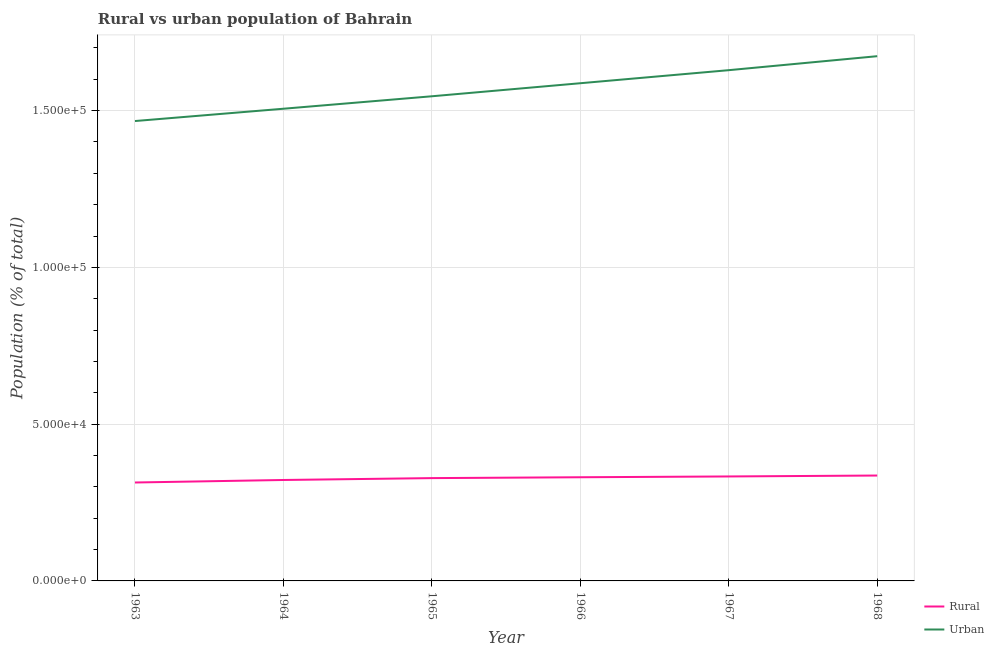Is the number of lines equal to the number of legend labels?
Offer a very short reply. Yes. What is the urban population density in 1966?
Offer a very short reply. 1.59e+05. Across all years, what is the maximum urban population density?
Your response must be concise. 1.67e+05. Across all years, what is the minimum urban population density?
Give a very brief answer. 1.47e+05. In which year was the rural population density maximum?
Your response must be concise. 1968. What is the total urban population density in the graph?
Keep it short and to the point. 9.41e+05. What is the difference between the urban population density in 1965 and that in 1967?
Make the answer very short. -8324. What is the difference between the urban population density in 1966 and the rural population density in 1963?
Your response must be concise. 1.27e+05. What is the average urban population density per year?
Offer a terse response. 1.57e+05. In the year 1963, what is the difference between the rural population density and urban population density?
Offer a terse response. -1.15e+05. What is the ratio of the rural population density in 1963 to that in 1964?
Your answer should be very brief. 0.98. Is the rural population density in 1967 less than that in 1968?
Provide a short and direct response. Yes. Is the difference between the urban population density in 1963 and 1964 greater than the difference between the rural population density in 1963 and 1964?
Ensure brevity in your answer.  No. What is the difference between the highest and the second highest rural population density?
Provide a short and direct response. 292. What is the difference between the highest and the lowest rural population density?
Keep it short and to the point. 2223. How many lines are there?
Your answer should be very brief. 2. How many years are there in the graph?
Ensure brevity in your answer.  6. Are the values on the major ticks of Y-axis written in scientific E-notation?
Your answer should be very brief. Yes. Does the graph contain any zero values?
Provide a short and direct response. No. Does the graph contain grids?
Offer a terse response. Yes. How many legend labels are there?
Offer a terse response. 2. How are the legend labels stacked?
Offer a very short reply. Vertical. What is the title of the graph?
Your answer should be compact. Rural vs urban population of Bahrain. Does "Money lenders" appear as one of the legend labels in the graph?
Make the answer very short. No. What is the label or title of the X-axis?
Your answer should be very brief. Year. What is the label or title of the Y-axis?
Your response must be concise. Population (% of total). What is the Population (% of total) in Rural in 1963?
Your answer should be very brief. 3.14e+04. What is the Population (% of total) in Urban in 1963?
Give a very brief answer. 1.47e+05. What is the Population (% of total) in Rural in 1964?
Your answer should be very brief. 3.22e+04. What is the Population (% of total) in Urban in 1964?
Ensure brevity in your answer.  1.51e+05. What is the Population (% of total) in Rural in 1965?
Keep it short and to the point. 3.28e+04. What is the Population (% of total) of Urban in 1965?
Ensure brevity in your answer.  1.55e+05. What is the Population (% of total) in Rural in 1966?
Give a very brief answer. 3.31e+04. What is the Population (% of total) in Urban in 1966?
Offer a terse response. 1.59e+05. What is the Population (% of total) of Rural in 1967?
Make the answer very short. 3.33e+04. What is the Population (% of total) of Urban in 1967?
Offer a terse response. 1.63e+05. What is the Population (% of total) in Rural in 1968?
Give a very brief answer. 3.36e+04. What is the Population (% of total) of Urban in 1968?
Your answer should be compact. 1.67e+05. Across all years, what is the maximum Population (% of total) in Rural?
Ensure brevity in your answer.  3.36e+04. Across all years, what is the maximum Population (% of total) in Urban?
Your answer should be very brief. 1.67e+05. Across all years, what is the minimum Population (% of total) of Rural?
Offer a very short reply. 3.14e+04. Across all years, what is the minimum Population (% of total) in Urban?
Offer a terse response. 1.47e+05. What is the total Population (% of total) of Rural in the graph?
Ensure brevity in your answer.  1.96e+05. What is the total Population (% of total) of Urban in the graph?
Make the answer very short. 9.41e+05. What is the difference between the Population (% of total) of Rural in 1963 and that in 1964?
Give a very brief answer. -802. What is the difference between the Population (% of total) in Urban in 1963 and that in 1964?
Keep it short and to the point. -3924. What is the difference between the Population (% of total) in Rural in 1963 and that in 1965?
Keep it short and to the point. -1400. What is the difference between the Population (% of total) of Urban in 1963 and that in 1965?
Ensure brevity in your answer.  -7900. What is the difference between the Population (% of total) of Rural in 1963 and that in 1966?
Offer a very short reply. -1675. What is the difference between the Population (% of total) of Urban in 1963 and that in 1966?
Offer a very short reply. -1.21e+04. What is the difference between the Population (% of total) in Rural in 1963 and that in 1967?
Offer a terse response. -1931. What is the difference between the Population (% of total) in Urban in 1963 and that in 1967?
Offer a terse response. -1.62e+04. What is the difference between the Population (% of total) of Rural in 1963 and that in 1968?
Offer a very short reply. -2223. What is the difference between the Population (% of total) in Urban in 1963 and that in 1968?
Make the answer very short. -2.07e+04. What is the difference between the Population (% of total) in Rural in 1964 and that in 1965?
Provide a short and direct response. -598. What is the difference between the Population (% of total) of Urban in 1964 and that in 1965?
Provide a succinct answer. -3976. What is the difference between the Population (% of total) of Rural in 1964 and that in 1966?
Make the answer very short. -873. What is the difference between the Population (% of total) of Urban in 1964 and that in 1966?
Provide a short and direct response. -8135. What is the difference between the Population (% of total) in Rural in 1964 and that in 1967?
Give a very brief answer. -1129. What is the difference between the Population (% of total) in Urban in 1964 and that in 1967?
Your answer should be compact. -1.23e+04. What is the difference between the Population (% of total) in Rural in 1964 and that in 1968?
Offer a very short reply. -1421. What is the difference between the Population (% of total) in Urban in 1964 and that in 1968?
Offer a terse response. -1.68e+04. What is the difference between the Population (% of total) of Rural in 1965 and that in 1966?
Your answer should be compact. -275. What is the difference between the Population (% of total) in Urban in 1965 and that in 1966?
Your response must be concise. -4159. What is the difference between the Population (% of total) of Rural in 1965 and that in 1967?
Your answer should be compact. -531. What is the difference between the Population (% of total) in Urban in 1965 and that in 1967?
Your answer should be very brief. -8324. What is the difference between the Population (% of total) in Rural in 1965 and that in 1968?
Keep it short and to the point. -823. What is the difference between the Population (% of total) in Urban in 1965 and that in 1968?
Ensure brevity in your answer.  -1.28e+04. What is the difference between the Population (% of total) of Rural in 1966 and that in 1967?
Offer a terse response. -256. What is the difference between the Population (% of total) in Urban in 1966 and that in 1967?
Offer a terse response. -4165. What is the difference between the Population (% of total) of Rural in 1966 and that in 1968?
Make the answer very short. -548. What is the difference between the Population (% of total) of Urban in 1966 and that in 1968?
Offer a very short reply. -8623. What is the difference between the Population (% of total) of Rural in 1967 and that in 1968?
Provide a succinct answer. -292. What is the difference between the Population (% of total) of Urban in 1967 and that in 1968?
Your answer should be very brief. -4458. What is the difference between the Population (% of total) in Rural in 1963 and the Population (% of total) in Urban in 1964?
Your answer should be compact. -1.19e+05. What is the difference between the Population (% of total) in Rural in 1963 and the Population (% of total) in Urban in 1965?
Offer a very short reply. -1.23e+05. What is the difference between the Population (% of total) in Rural in 1963 and the Population (% of total) in Urban in 1966?
Provide a succinct answer. -1.27e+05. What is the difference between the Population (% of total) of Rural in 1963 and the Population (% of total) of Urban in 1967?
Provide a short and direct response. -1.32e+05. What is the difference between the Population (% of total) in Rural in 1963 and the Population (% of total) in Urban in 1968?
Keep it short and to the point. -1.36e+05. What is the difference between the Population (% of total) of Rural in 1964 and the Population (% of total) of Urban in 1965?
Offer a terse response. -1.22e+05. What is the difference between the Population (% of total) of Rural in 1964 and the Population (% of total) of Urban in 1966?
Keep it short and to the point. -1.27e+05. What is the difference between the Population (% of total) in Rural in 1964 and the Population (% of total) in Urban in 1967?
Offer a terse response. -1.31e+05. What is the difference between the Population (% of total) of Rural in 1964 and the Population (% of total) of Urban in 1968?
Offer a terse response. -1.35e+05. What is the difference between the Population (% of total) in Rural in 1965 and the Population (% of total) in Urban in 1966?
Keep it short and to the point. -1.26e+05. What is the difference between the Population (% of total) in Rural in 1965 and the Population (% of total) in Urban in 1967?
Your response must be concise. -1.30e+05. What is the difference between the Population (% of total) in Rural in 1965 and the Population (% of total) in Urban in 1968?
Give a very brief answer. -1.35e+05. What is the difference between the Population (% of total) in Rural in 1966 and the Population (% of total) in Urban in 1967?
Ensure brevity in your answer.  -1.30e+05. What is the difference between the Population (% of total) in Rural in 1966 and the Population (% of total) in Urban in 1968?
Offer a terse response. -1.34e+05. What is the difference between the Population (% of total) in Rural in 1967 and the Population (% of total) in Urban in 1968?
Your answer should be very brief. -1.34e+05. What is the average Population (% of total) in Rural per year?
Offer a terse response. 3.27e+04. What is the average Population (% of total) of Urban per year?
Give a very brief answer. 1.57e+05. In the year 1963, what is the difference between the Population (% of total) in Rural and Population (% of total) in Urban?
Keep it short and to the point. -1.15e+05. In the year 1964, what is the difference between the Population (% of total) of Rural and Population (% of total) of Urban?
Ensure brevity in your answer.  -1.18e+05. In the year 1965, what is the difference between the Population (% of total) in Rural and Population (% of total) in Urban?
Provide a short and direct response. -1.22e+05. In the year 1966, what is the difference between the Population (% of total) in Rural and Population (% of total) in Urban?
Keep it short and to the point. -1.26e+05. In the year 1967, what is the difference between the Population (% of total) in Rural and Population (% of total) in Urban?
Your response must be concise. -1.30e+05. In the year 1968, what is the difference between the Population (% of total) of Rural and Population (% of total) of Urban?
Ensure brevity in your answer.  -1.34e+05. What is the ratio of the Population (% of total) of Rural in 1963 to that in 1964?
Give a very brief answer. 0.98. What is the ratio of the Population (% of total) of Urban in 1963 to that in 1964?
Provide a succinct answer. 0.97. What is the ratio of the Population (% of total) in Rural in 1963 to that in 1965?
Provide a short and direct response. 0.96. What is the ratio of the Population (% of total) of Urban in 1963 to that in 1965?
Offer a terse response. 0.95. What is the ratio of the Population (% of total) in Rural in 1963 to that in 1966?
Your answer should be compact. 0.95. What is the ratio of the Population (% of total) of Urban in 1963 to that in 1966?
Keep it short and to the point. 0.92. What is the ratio of the Population (% of total) of Rural in 1963 to that in 1967?
Make the answer very short. 0.94. What is the ratio of the Population (% of total) in Urban in 1963 to that in 1967?
Keep it short and to the point. 0.9. What is the ratio of the Population (% of total) of Rural in 1963 to that in 1968?
Keep it short and to the point. 0.93. What is the ratio of the Population (% of total) in Urban in 1963 to that in 1968?
Offer a very short reply. 0.88. What is the ratio of the Population (% of total) of Rural in 1964 to that in 1965?
Ensure brevity in your answer.  0.98. What is the ratio of the Population (% of total) in Urban in 1964 to that in 1965?
Your answer should be very brief. 0.97. What is the ratio of the Population (% of total) in Rural in 1964 to that in 1966?
Keep it short and to the point. 0.97. What is the ratio of the Population (% of total) of Urban in 1964 to that in 1966?
Provide a succinct answer. 0.95. What is the ratio of the Population (% of total) in Rural in 1964 to that in 1967?
Provide a succinct answer. 0.97. What is the ratio of the Population (% of total) in Urban in 1964 to that in 1967?
Offer a very short reply. 0.92. What is the ratio of the Population (% of total) in Rural in 1964 to that in 1968?
Provide a short and direct response. 0.96. What is the ratio of the Population (% of total) of Urban in 1964 to that in 1968?
Your answer should be compact. 0.9. What is the ratio of the Population (% of total) in Urban in 1965 to that in 1966?
Your response must be concise. 0.97. What is the ratio of the Population (% of total) of Rural in 1965 to that in 1967?
Offer a very short reply. 0.98. What is the ratio of the Population (% of total) in Urban in 1965 to that in 1967?
Offer a very short reply. 0.95. What is the ratio of the Population (% of total) in Rural in 1965 to that in 1968?
Offer a terse response. 0.98. What is the ratio of the Population (% of total) of Urban in 1965 to that in 1968?
Provide a succinct answer. 0.92. What is the ratio of the Population (% of total) in Urban in 1966 to that in 1967?
Make the answer very short. 0.97. What is the ratio of the Population (% of total) in Rural in 1966 to that in 1968?
Your response must be concise. 0.98. What is the ratio of the Population (% of total) in Urban in 1966 to that in 1968?
Give a very brief answer. 0.95. What is the ratio of the Population (% of total) of Urban in 1967 to that in 1968?
Your answer should be compact. 0.97. What is the difference between the highest and the second highest Population (% of total) of Rural?
Keep it short and to the point. 292. What is the difference between the highest and the second highest Population (% of total) in Urban?
Give a very brief answer. 4458. What is the difference between the highest and the lowest Population (% of total) of Rural?
Provide a succinct answer. 2223. What is the difference between the highest and the lowest Population (% of total) of Urban?
Provide a short and direct response. 2.07e+04. 